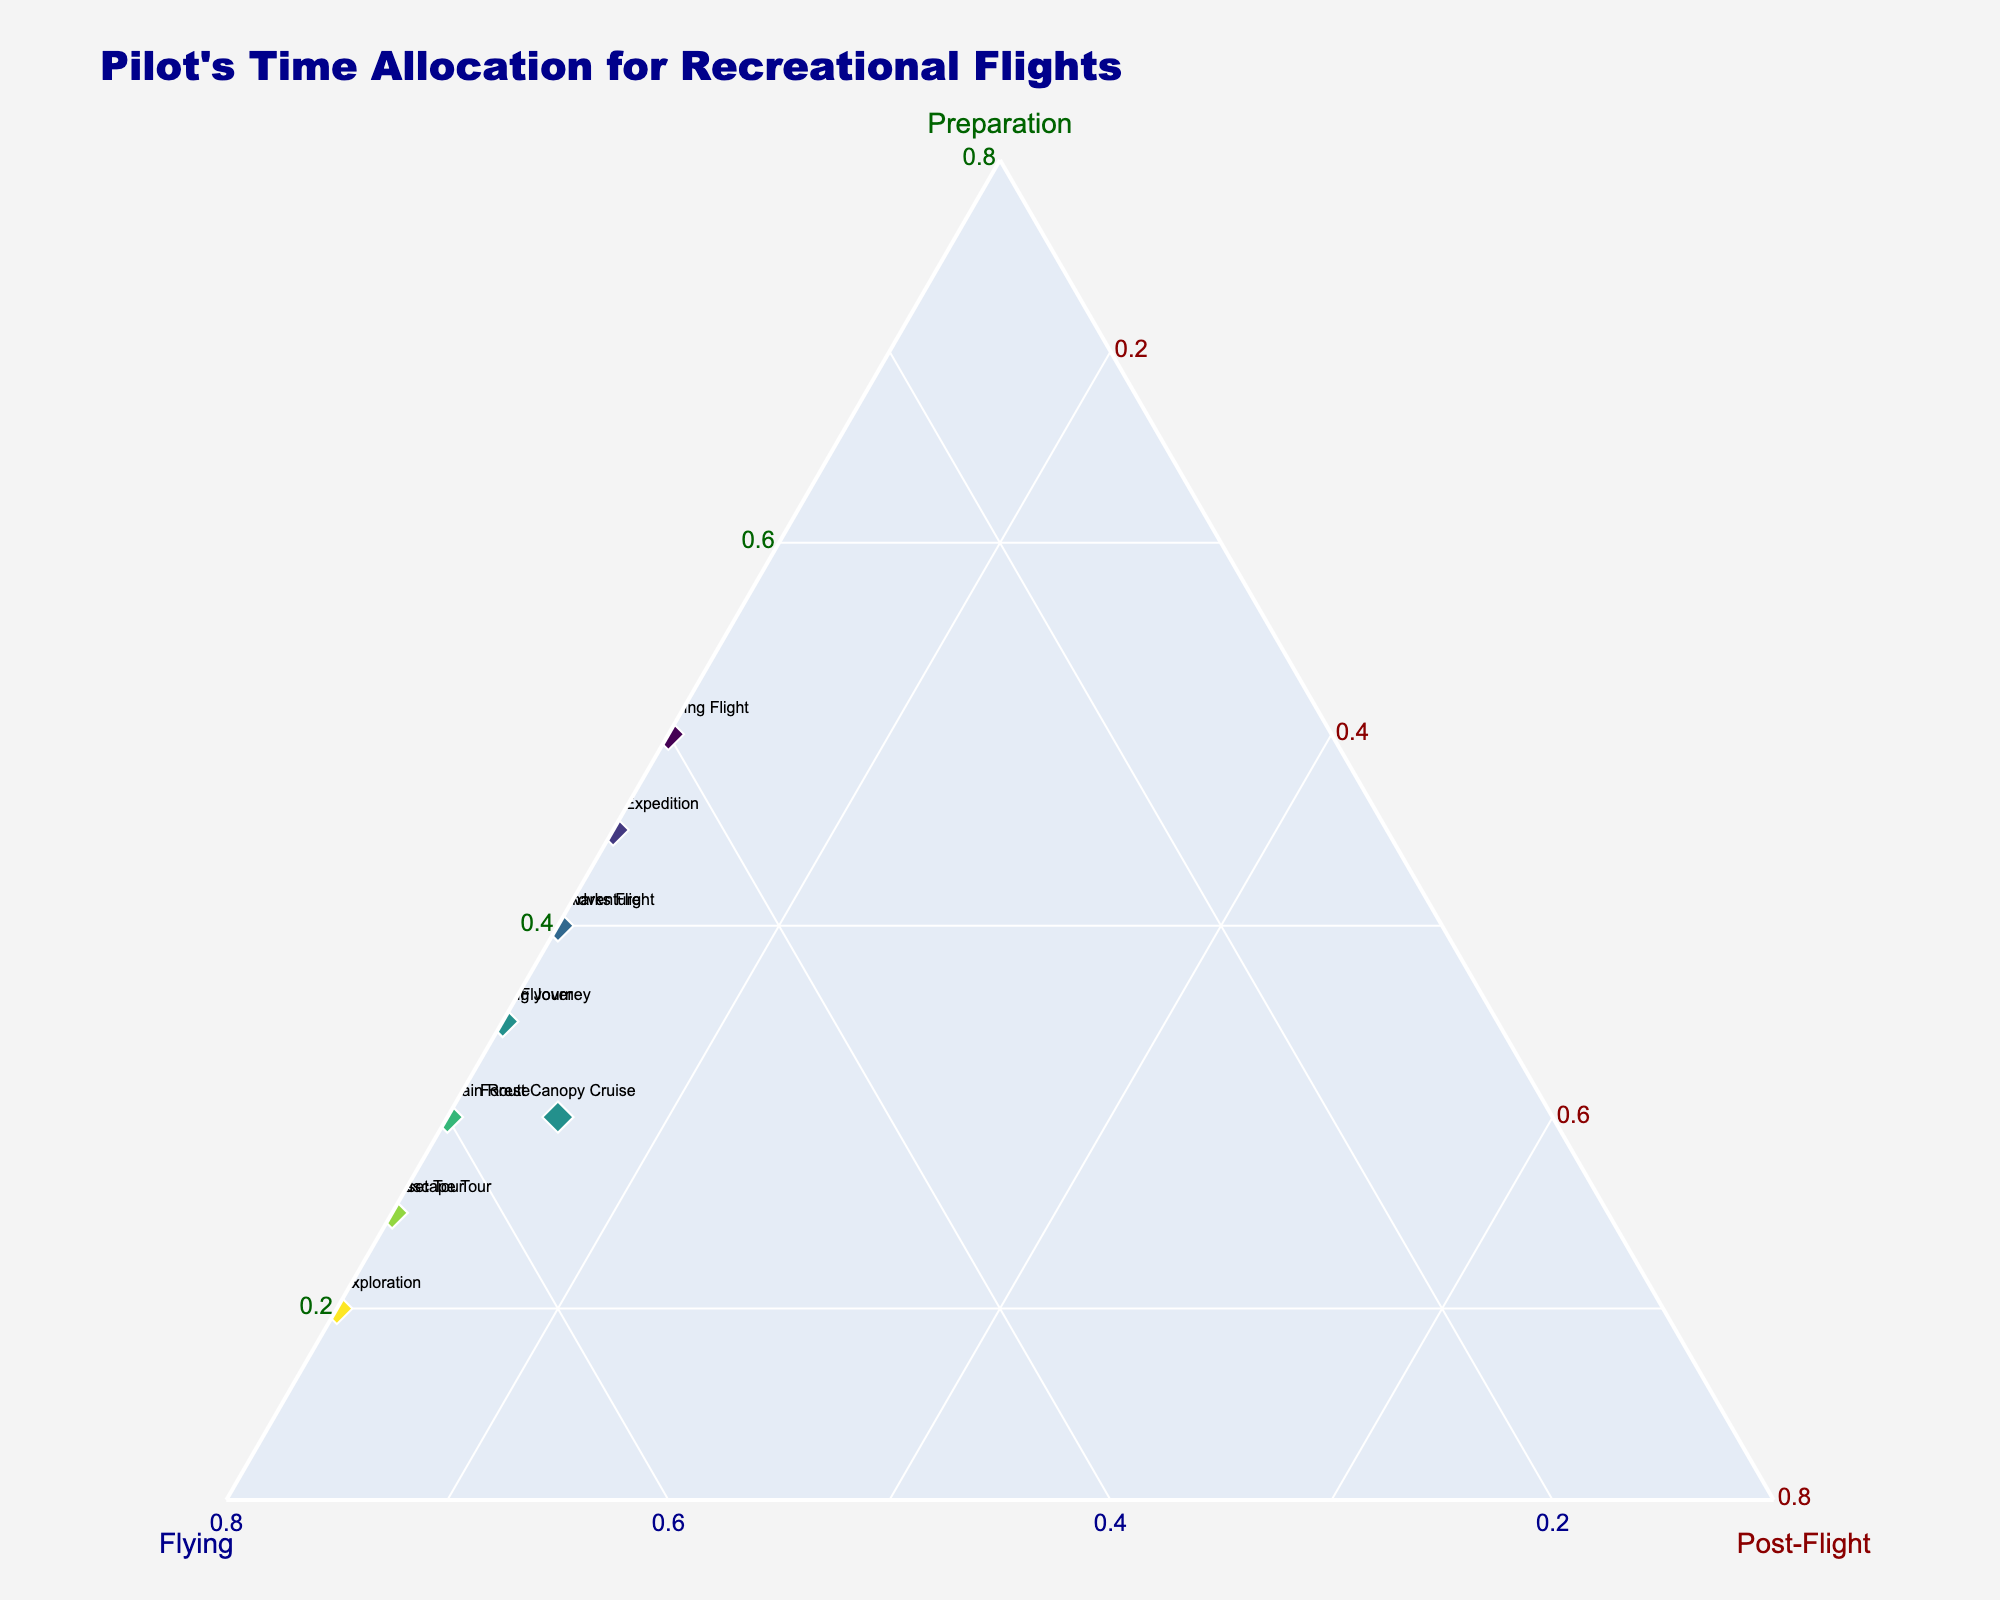what is the title of the figure? The title is typically placed at the top of the plot and is formatted to be noticeable. By looking at the top section of the figure, you should see the text.
Answer: Pilot's Time Allocation for Recreational Flights which flight has the highest allocation for preparation? Identify the point that is furthest along the 'Preparation' axis, which is typically on the left side of the plot. The length of the segment will indicate the maximum value.
Answer: Volcano Viewing Flight how many flights allocate 10% of their time for post-flight? Look for the markers located near the 'Post-Flight' axis, which shows an allocation of 10%. Count the number of points.
Answer: 10 which flight has an equal allocation between preparation and flying? Equal allocation between preparation and flying means the points should be equidistant from both 'Preparation' and 'Flying' axes. Locate this balanced point on the plot.
Answer: Desert Oasis Expedition what is the average allocation time for flying across all flights? Sum up all the values given for the flying time and then divide by the number of flights. (60+65+55+50+45+55+60+70+40+65+50+55) / 12 = 58.33
Answer: 58.33% which flight has the least time allocated for flying? Identify the point closest to the origin on the 'Flying' axis, indicated by the axis that goes from the bottom to the top center. Check the value corresponding to this point.
Answer: Volcano Viewing Flight how much more time does the Coastal Sunset Tour allocate to flying than the Scenic Mountain Route? Subtract the flying time of the Scenic Mountain Route from the Coastal Sunset Tour. 65 - 60 = 5
Answer: 5% which flight is closest to having an equal third split in time allocation? An equal third split would be found at the center of the ternary plot (where all three axes intersect at equal lengths). Find the point closest to this central position.
Answer: Forest Canopy Cruise what is the combined preparation and post-flight time for the City Skyline Flyover? Add the preparation time and post-flight time for this specific flight. 35 + 10 = 45
Answer: 45% which flight is most dominated by flying time? Identify the point that is furthest along the 'Flying' axis, which indicates the highest allocation for flying. Look for the marker near the top of the plot.
Answer: River Valley Exploration 